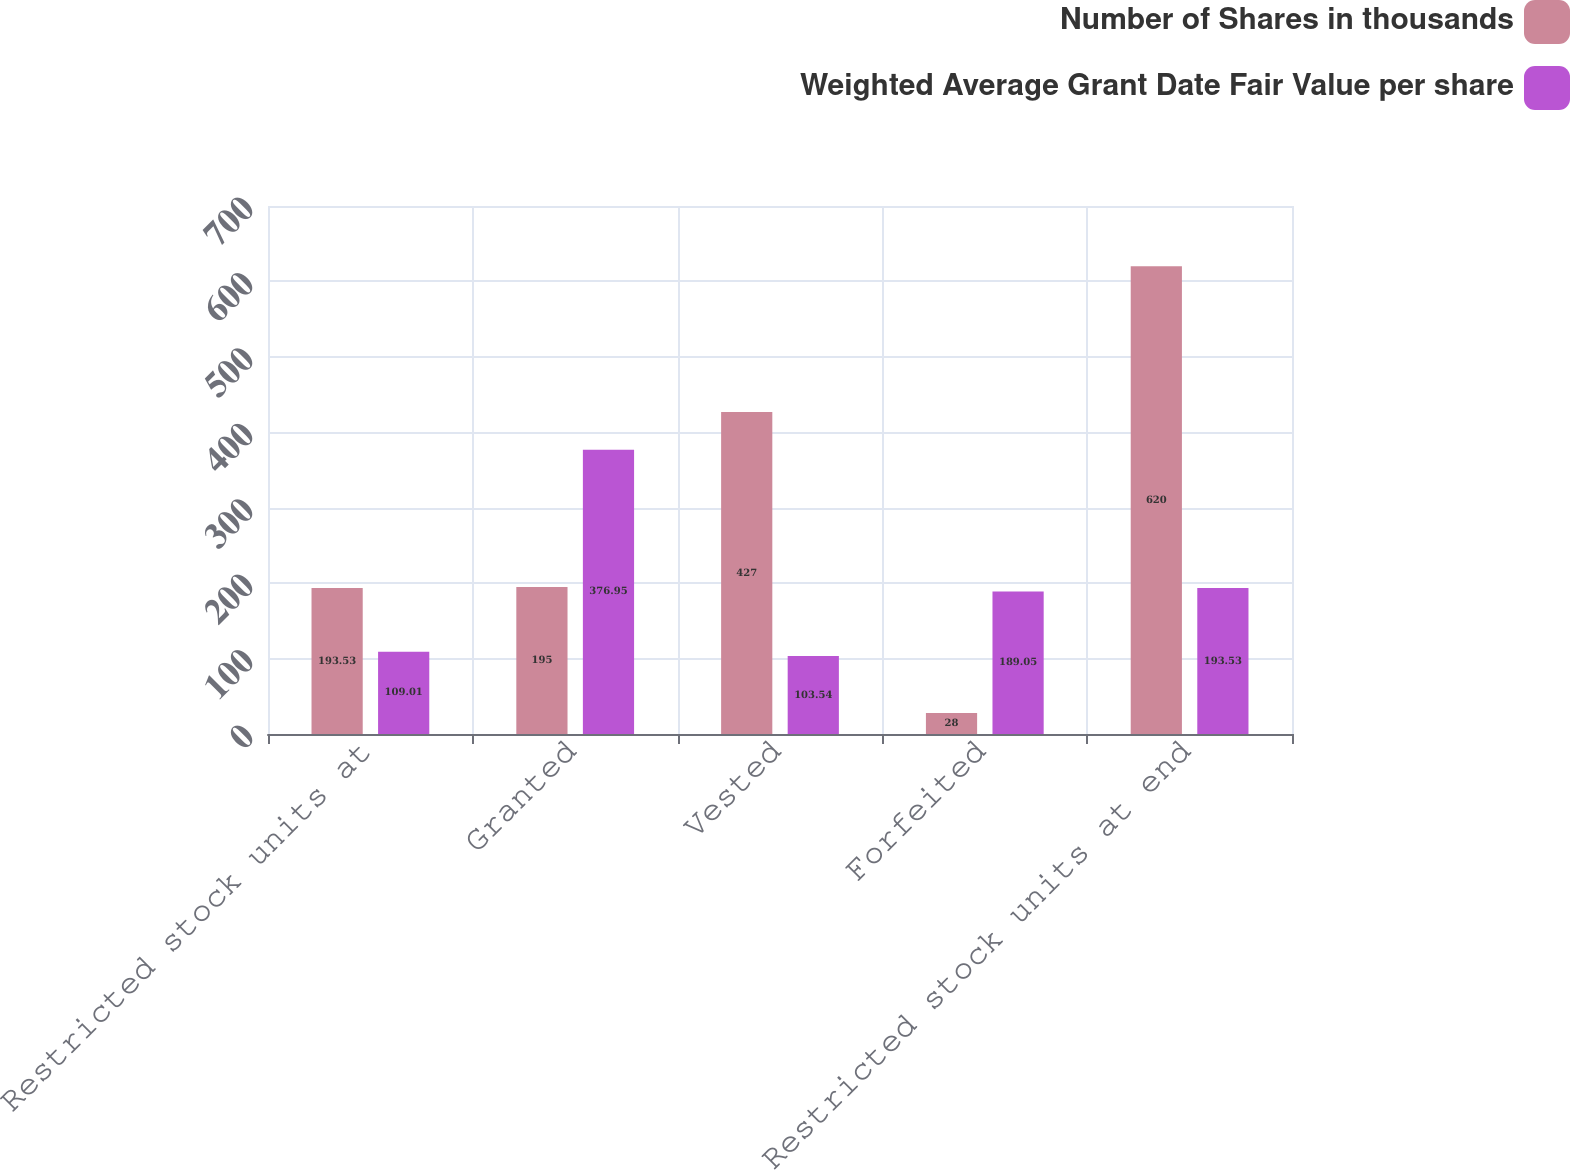Convert chart. <chart><loc_0><loc_0><loc_500><loc_500><stacked_bar_chart><ecel><fcel>Restricted stock units at<fcel>Granted<fcel>Vested<fcel>Forfeited<fcel>Restricted stock units at end<nl><fcel>Number of Shares in thousands<fcel>193.53<fcel>195<fcel>427<fcel>28<fcel>620<nl><fcel>Weighted Average Grant Date Fair Value per share<fcel>109.01<fcel>376.95<fcel>103.54<fcel>189.05<fcel>193.53<nl></chart> 